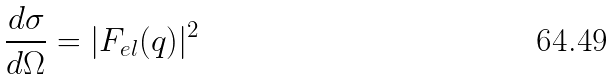Convert formula to latex. <formula><loc_0><loc_0><loc_500><loc_500>\frac { d \sigma } { d \Omega } = | F _ { e l } ( q ) | ^ { 2 }</formula> 